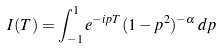<formula> <loc_0><loc_0><loc_500><loc_500>I ( T ) = \int _ { - 1 } ^ { 1 } e ^ { - i p T } ( 1 - p ^ { 2 } ) ^ { - \alpha } \, d p</formula> 